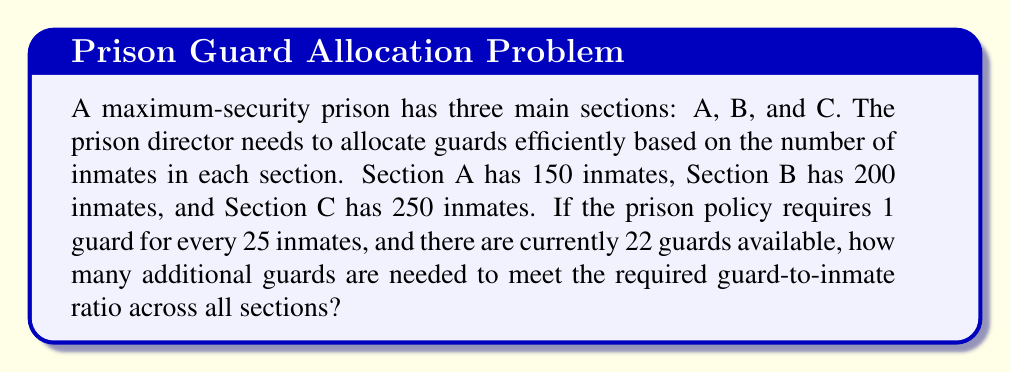Provide a solution to this math problem. Let's approach this problem step-by-step:

1. Calculate the total number of inmates:
   $$ \text{Total inmates} = 150 + 200 + 250 = 600 $$

2. Calculate the required number of guards based on the policy:
   $$ \text{Required guards} = \frac{\text{Total inmates}}{\text{Inmates per guard}} = \frac{600}{25} = 24 $$

3. Find the difference between required guards and available guards:
   $$ \text{Additional guards needed} = \text{Required guards} - \text{Available guards} $$
   $$ \text{Additional guards needed} = 24 - 22 = 2 $$

Therefore, 2 additional guards are needed to meet the required guard-to-inmate ratio across all sections.
Answer: 2 additional guards 